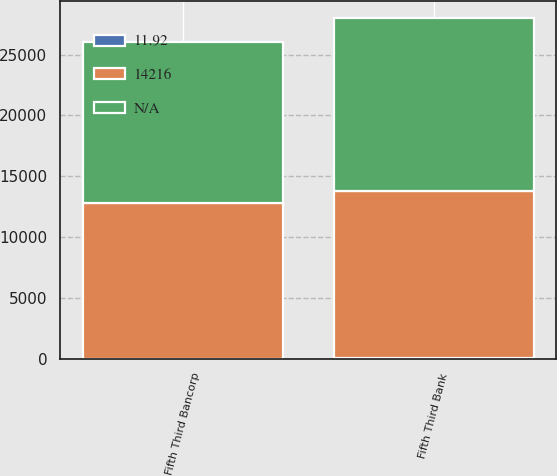Convert chart to OTSL. <chart><loc_0><loc_0><loc_500><loc_500><stacked_bar_chart><ecel><fcel>Fifth Third Bancorp<fcel>Fifth Third Bank<nl><fcel>nan<fcel>13260<fcel>14216<nl><fcel>11.92<fcel>10.93<fcel>11.92<nl><fcel>14216<fcel>12764<fcel>13760<nl></chart> 